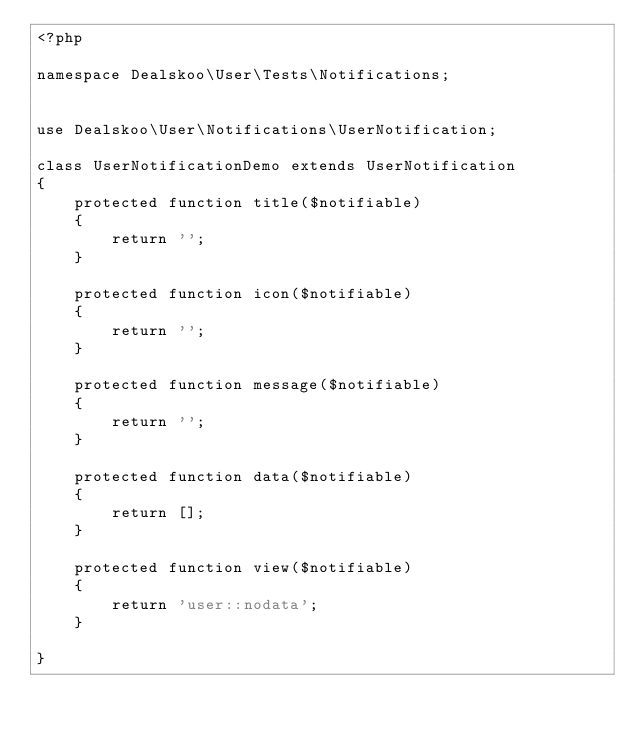<code> <loc_0><loc_0><loc_500><loc_500><_PHP_><?php

namespace Dealskoo\User\Tests\Notifications;


use Dealskoo\User\Notifications\UserNotification;

class UserNotificationDemo extends UserNotification
{
    protected function title($notifiable)
    {
        return '';
    }

    protected function icon($notifiable)
    {
        return '';
    }

    protected function message($notifiable)
    {
        return '';
    }

    protected function data($notifiable)
    {
        return [];
    }

    protected function view($notifiable)
    {
        return 'user::nodata';
    }

}
</code> 